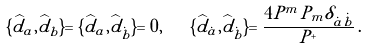<formula> <loc_0><loc_0><loc_500><loc_500>\{ \widehat { d } _ { a } , \widehat { d } _ { b } \} = \{ \widehat { d } _ { a } , \widehat { d } _ { \dot { b } } \} = 0 , \quad \{ \widehat { d } _ { \dot { a } } , \widehat { d } _ { \dot { b } } \} = \frac { 4 P ^ { m } P _ { m } \delta _ { \dot { a } \dot { b } } } { P ^ { + } } \, .</formula> 